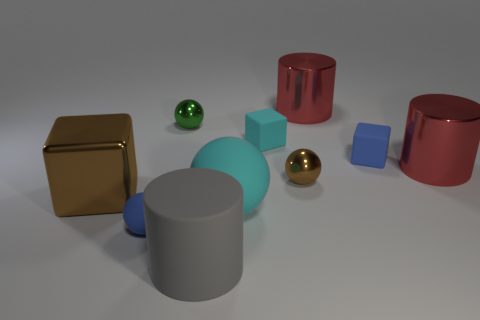What material is the cyan cube that is the same size as the blue sphere?
Give a very brief answer. Rubber. There is a ball that is the same color as the large metal cube; what material is it?
Provide a short and direct response. Metal. There is a large sphere that is made of the same material as the large gray cylinder; what color is it?
Your answer should be very brief. Cyan. Is the number of tiny brown metallic balls that are in front of the large cube less than the number of metal spheres that are on the right side of the large gray thing?
Offer a terse response. Yes. Does the cylinder behind the tiny green object have the same color as the big metal thing that is to the left of the cyan ball?
Ensure brevity in your answer.  No. Is there a blue object made of the same material as the large gray thing?
Ensure brevity in your answer.  Yes. What size is the matte block that is right of the red cylinder that is behind the green ball?
Your response must be concise. Small. Are there more big blue cylinders than small spheres?
Offer a terse response. No. Is the size of the blue thing that is right of the gray object the same as the gray object?
Your answer should be very brief. No. How many large shiny cylinders are the same color as the big metal cube?
Your answer should be compact. 0. 